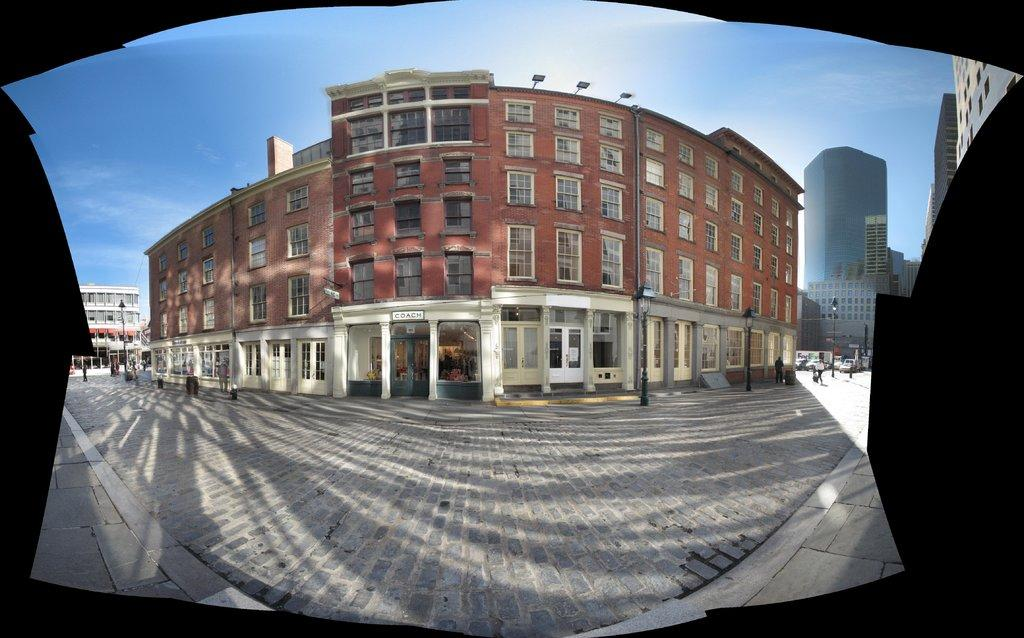What type of structures can be seen in the image? There are buildings in the image. What else can be seen in the image besides buildings? There are poles and boards visible in the image. Are there any living beings in the image? Yes, there are people in the image. What can be seen in the background of the image? The sky is visible in the background of the image. What type of dolls can be seen playing with paper in the image? There are no dolls or paper present in the image. 